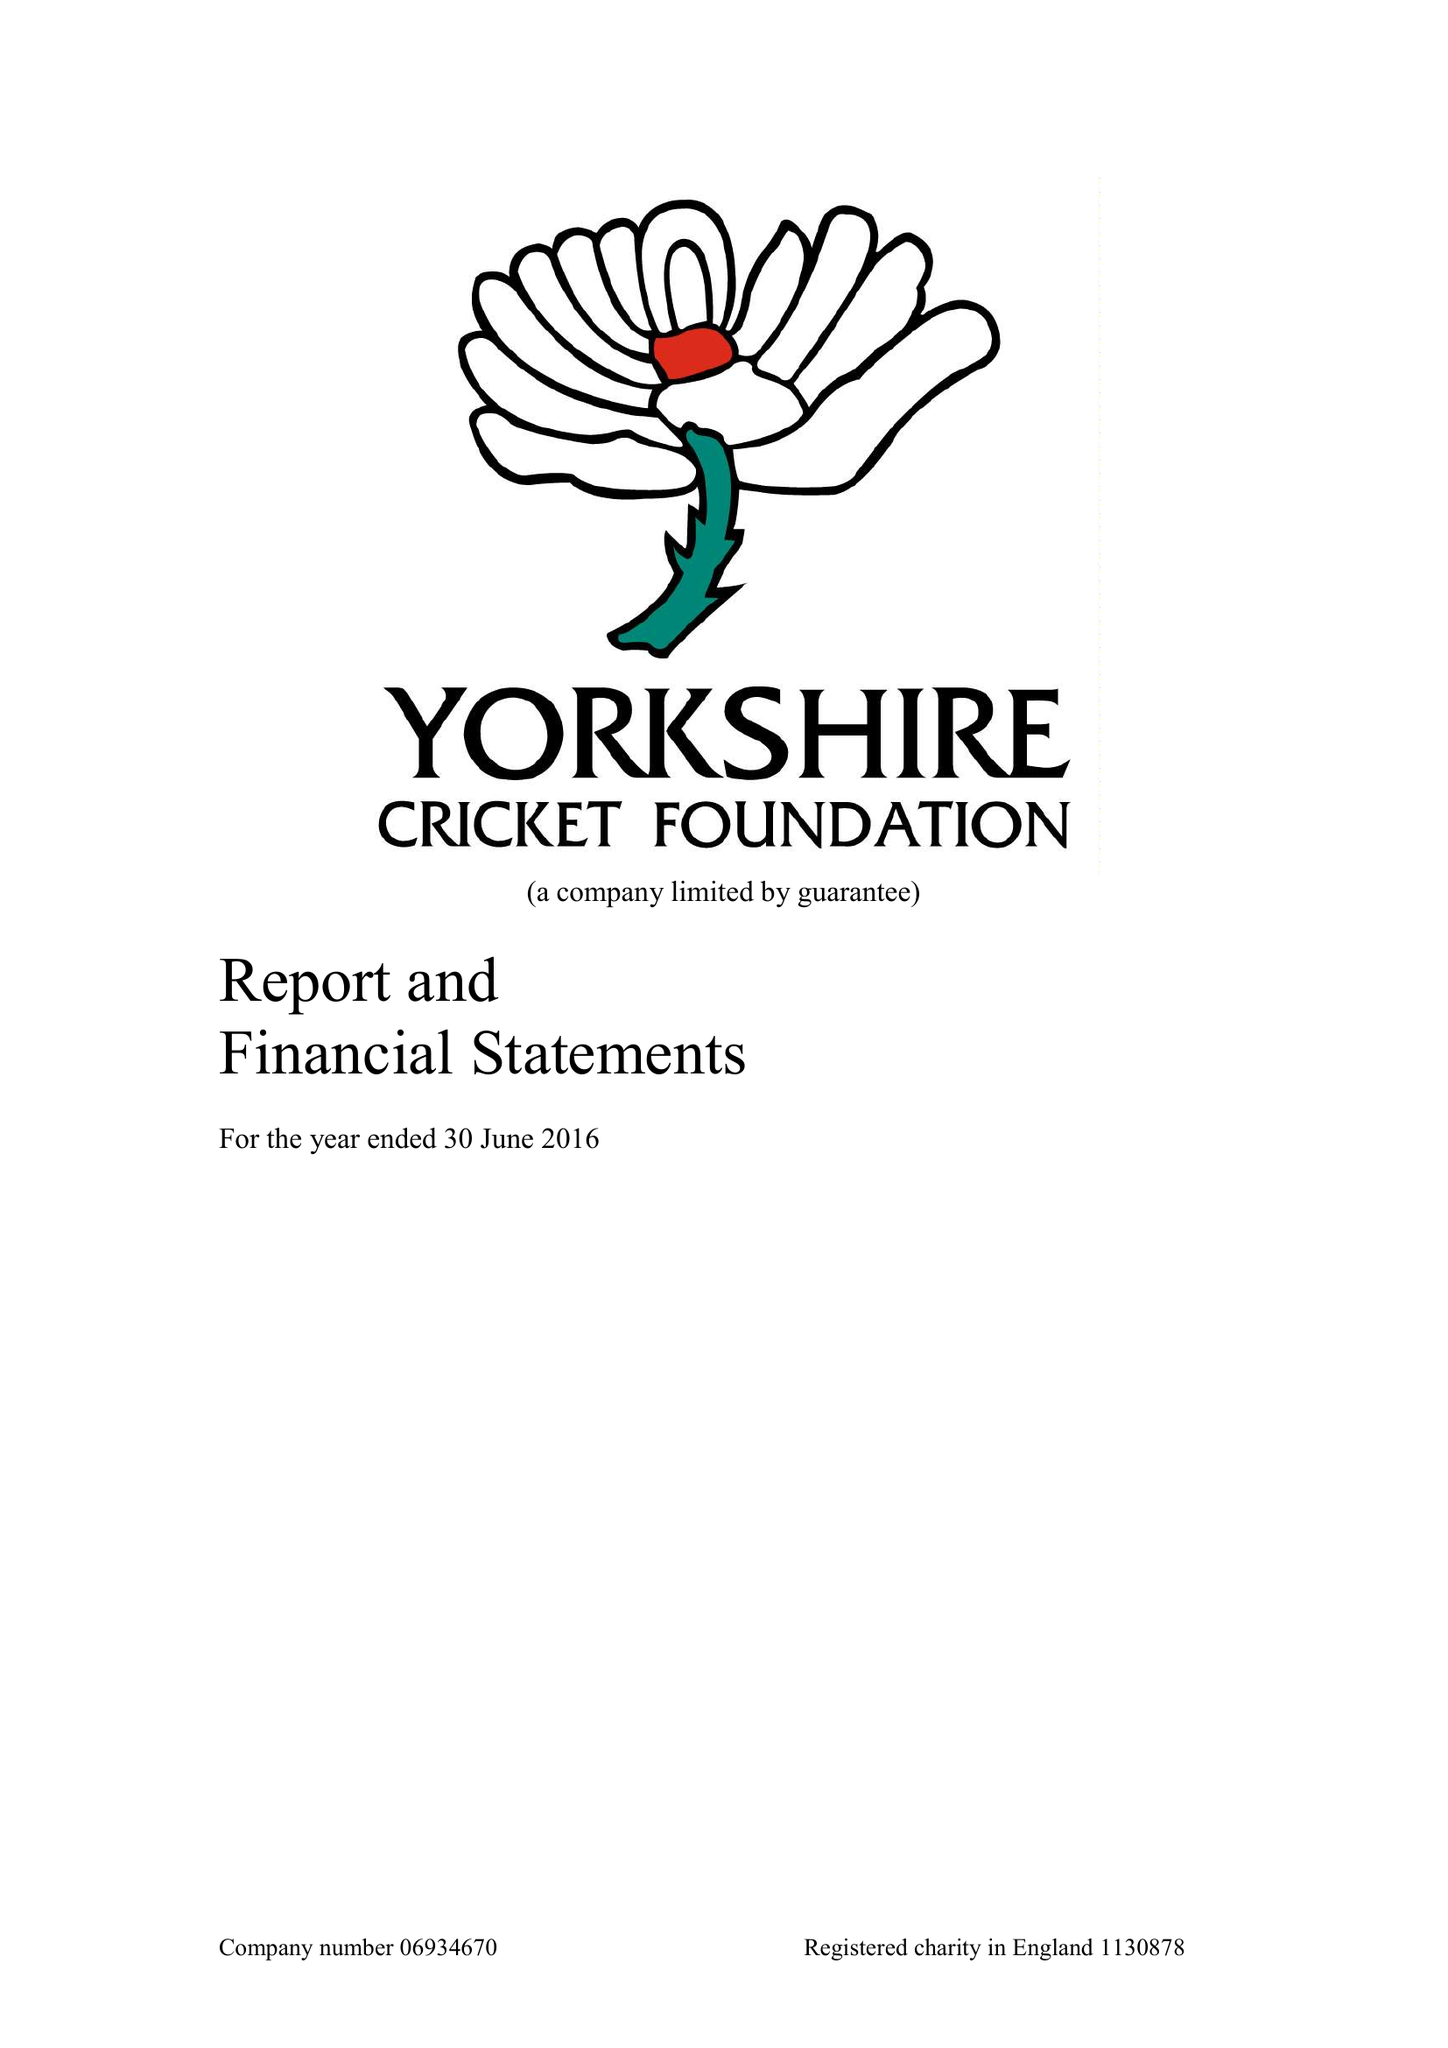What is the value for the address__street_line?
Answer the question using a single word or phrase. KIRKSTALL LANE 